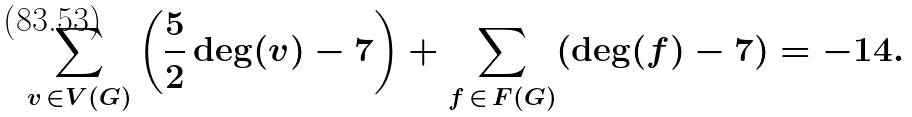<formula> <loc_0><loc_0><loc_500><loc_500>\sum _ { v \, \in V ( G ) } \left ( \frac { 5 } { 2 } \deg ( v ) - 7 \right ) + \sum _ { f \, \in \, F ( G ) } ( \deg ( f ) - 7 ) = - 1 4 .</formula> 